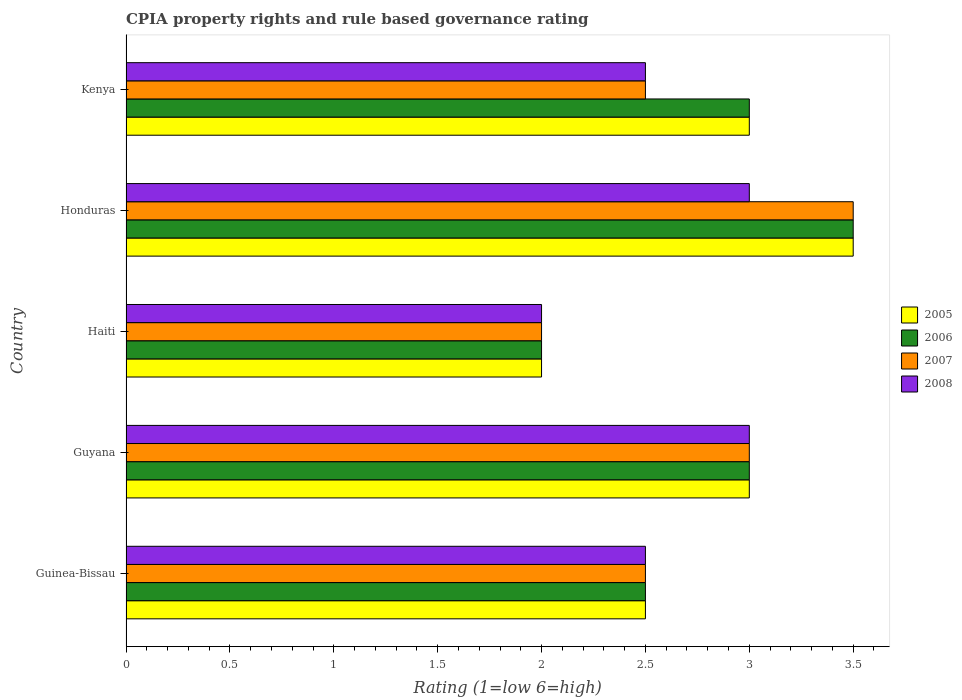Are the number of bars per tick equal to the number of legend labels?
Ensure brevity in your answer.  Yes. Are the number of bars on each tick of the Y-axis equal?
Offer a very short reply. Yes. How many bars are there on the 5th tick from the top?
Keep it short and to the point. 4. What is the label of the 2nd group of bars from the top?
Your response must be concise. Honduras. In how many cases, is the number of bars for a given country not equal to the number of legend labels?
Ensure brevity in your answer.  0. Across all countries, what is the minimum CPIA rating in 2007?
Your answer should be compact. 2. In which country was the CPIA rating in 2006 maximum?
Your response must be concise. Honduras. In which country was the CPIA rating in 2007 minimum?
Make the answer very short. Haiti. What is the total CPIA rating in 2007 in the graph?
Provide a succinct answer. 13.5. What is the difference between the CPIA rating in 2005 in Haiti and the CPIA rating in 2007 in Kenya?
Offer a very short reply. -0.5. In how many countries, is the CPIA rating in 2007 greater than 2.8 ?
Your answer should be very brief. 2. What is the ratio of the CPIA rating in 2006 in Guinea-Bissau to that in Honduras?
Offer a very short reply. 0.71. Is the difference between the CPIA rating in 2008 in Guyana and Kenya greater than the difference between the CPIA rating in 2005 in Guyana and Kenya?
Offer a terse response. Yes. What is the difference between the highest and the lowest CPIA rating in 2007?
Offer a terse response. 1.5. Is it the case that in every country, the sum of the CPIA rating in 2005 and CPIA rating in 2006 is greater than the sum of CPIA rating in 2007 and CPIA rating in 2008?
Offer a terse response. No. Is it the case that in every country, the sum of the CPIA rating in 2008 and CPIA rating in 2005 is greater than the CPIA rating in 2007?
Your answer should be very brief. Yes. How many bars are there?
Make the answer very short. 20. How many countries are there in the graph?
Offer a very short reply. 5. What is the difference between two consecutive major ticks on the X-axis?
Give a very brief answer. 0.5. Does the graph contain any zero values?
Make the answer very short. No. Does the graph contain grids?
Provide a short and direct response. No. Where does the legend appear in the graph?
Provide a succinct answer. Center right. How many legend labels are there?
Your answer should be very brief. 4. What is the title of the graph?
Provide a succinct answer. CPIA property rights and rule based governance rating. What is the label or title of the Y-axis?
Provide a short and direct response. Country. What is the Rating (1=low 6=high) in 2005 in Guinea-Bissau?
Make the answer very short. 2.5. What is the Rating (1=low 6=high) of 2005 in Guyana?
Your answer should be compact. 3. What is the Rating (1=low 6=high) of 2006 in Guyana?
Provide a succinct answer. 3. What is the Rating (1=low 6=high) in 2007 in Guyana?
Your answer should be very brief. 3. What is the Rating (1=low 6=high) of 2008 in Guyana?
Your response must be concise. 3. What is the Rating (1=low 6=high) in 2006 in Haiti?
Offer a terse response. 2. What is the Rating (1=low 6=high) in 2005 in Honduras?
Offer a terse response. 3.5. What is the Rating (1=low 6=high) of 2008 in Honduras?
Ensure brevity in your answer.  3. What is the Rating (1=low 6=high) of 2005 in Kenya?
Offer a terse response. 3. What is the Rating (1=low 6=high) in 2006 in Kenya?
Offer a very short reply. 3. Across all countries, what is the maximum Rating (1=low 6=high) in 2006?
Offer a terse response. 3.5. Across all countries, what is the maximum Rating (1=low 6=high) in 2007?
Provide a succinct answer. 3.5. Across all countries, what is the minimum Rating (1=low 6=high) in 2005?
Your response must be concise. 2. Across all countries, what is the minimum Rating (1=low 6=high) of 2008?
Offer a very short reply. 2. What is the total Rating (1=low 6=high) in 2007 in the graph?
Make the answer very short. 13.5. What is the total Rating (1=low 6=high) in 2008 in the graph?
Provide a succinct answer. 13. What is the difference between the Rating (1=low 6=high) of 2005 in Guinea-Bissau and that in Guyana?
Keep it short and to the point. -0.5. What is the difference between the Rating (1=low 6=high) of 2006 in Guinea-Bissau and that in Guyana?
Make the answer very short. -0.5. What is the difference between the Rating (1=low 6=high) in 2006 in Guinea-Bissau and that in Haiti?
Provide a short and direct response. 0.5. What is the difference between the Rating (1=low 6=high) in 2007 in Guinea-Bissau and that in Haiti?
Make the answer very short. 0.5. What is the difference between the Rating (1=low 6=high) of 2008 in Guinea-Bissau and that in Haiti?
Your response must be concise. 0.5. What is the difference between the Rating (1=low 6=high) in 2005 in Guinea-Bissau and that in Honduras?
Give a very brief answer. -1. What is the difference between the Rating (1=low 6=high) in 2006 in Guinea-Bissau and that in Honduras?
Provide a succinct answer. -1. What is the difference between the Rating (1=low 6=high) of 2007 in Guinea-Bissau and that in Honduras?
Provide a short and direct response. -1. What is the difference between the Rating (1=low 6=high) in 2008 in Guinea-Bissau and that in Kenya?
Provide a succinct answer. 0. What is the difference between the Rating (1=low 6=high) of 2005 in Guyana and that in Haiti?
Offer a very short reply. 1. What is the difference between the Rating (1=low 6=high) in 2006 in Guyana and that in Haiti?
Keep it short and to the point. 1. What is the difference between the Rating (1=low 6=high) of 2008 in Guyana and that in Haiti?
Make the answer very short. 1. What is the difference between the Rating (1=low 6=high) in 2005 in Guyana and that in Honduras?
Make the answer very short. -0.5. What is the difference between the Rating (1=low 6=high) of 2007 in Guyana and that in Honduras?
Ensure brevity in your answer.  -0.5. What is the difference between the Rating (1=low 6=high) in 2008 in Guyana and that in Honduras?
Offer a very short reply. 0. What is the difference between the Rating (1=low 6=high) of 2007 in Guyana and that in Kenya?
Your answer should be very brief. 0.5. What is the difference between the Rating (1=low 6=high) in 2006 in Haiti and that in Honduras?
Provide a short and direct response. -1.5. What is the difference between the Rating (1=low 6=high) in 2008 in Haiti and that in Kenya?
Your answer should be very brief. -0.5. What is the difference between the Rating (1=low 6=high) of 2005 in Honduras and that in Kenya?
Provide a short and direct response. 0.5. What is the difference between the Rating (1=low 6=high) of 2006 in Honduras and that in Kenya?
Provide a short and direct response. 0.5. What is the difference between the Rating (1=low 6=high) in 2007 in Honduras and that in Kenya?
Your answer should be compact. 1. What is the difference between the Rating (1=low 6=high) in 2005 in Guinea-Bissau and the Rating (1=low 6=high) in 2006 in Guyana?
Offer a terse response. -0.5. What is the difference between the Rating (1=low 6=high) of 2005 in Guinea-Bissau and the Rating (1=low 6=high) of 2007 in Guyana?
Your response must be concise. -0.5. What is the difference between the Rating (1=low 6=high) in 2005 in Guinea-Bissau and the Rating (1=low 6=high) in 2008 in Guyana?
Your response must be concise. -0.5. What is the difference between the Rating (1=low 6=high) in 2006 in Guinea-Bissau and the Rating (1=low 6=high) in 2007 in Guyana?
Keep it short and to the point. -0.5. What is the difference between the Rating (1=low 6=high) in 2006 in Guinea-Bissau and the Rating (1=low 6=high) in 2008 in Guyana?
Offer a terse response. -0.5. What is the difference between the Rating (1=low 6=high) in 2006 in Guinea-Bissau and the Rating (1=low 6=high) in 2007 in Haiti?
Provide a succinct answer. 0.5. What is the difference between the Rating (1=low 6=high) in 2006 in Guinea-Bissau and the Rating (1=low 6=high) in 2008 in Haiti?
Keep it short and to the point. 0.5. What is the difference between the Rating (1=low 6=high) in 2007 in Guinea-Bissau and the Rating (1=low 6=high) in 2008 in Haiti?
Offer a very short reply. 0.5. What is the difference between the Rating (1=low 6=high) in 2006 in Guinea-Bissau and the Rating (1=low 6=high) in 2008 in Honduras?
Keep it short and to the point. -0.5. What is the difference between the Rating (1=low 6=high) of 2005 in Guinea-Bissau and the Rating (1=low 6=high) of 2006 in Kenya?
Keep it short and to the point. -0.5. What is the difference between the Rating (1=low 6=high) in 2005 in Guinea-Bissau and the Rating (1=low 6=high) in 2007 in Kenya?
Give a very brief answer. 0. What is the difference between the Rating (1=low 6=high) in 2007 in Guinea-Bissau and the Rating (1=low 6=high) in 2008 in Kenya?
Your response must be concise. 0. What is the difference between the Rating (1=low 6=high) in 2005 in Guyana and the Rating (1=low 6=high) in 2007 in Haiti?
Your response must be concise. 1. What is the difference between the Rating (1=low 6=high) in 2005 in Guyana and the Rating (1=low 6=high) in 2008 in Haiti?
Make the answer very short. 1. What is the difference between the Rating (1=low 6=high) of 2006 in Guyana and the Rating (1=low 6=high) of 2007 in Haiti?
Make the answer very short. 1. What is the difference between the Rating (1=low 6=high) of 2005 in Guyana and the Rating (1=low 6=high) of 2007 in Honduras?
Offer a terse response. -0.5. What is the difference between the Rating (1=low 6=high) in 2005 in Guyana and the Rating (1=low 6=high) in 2007 in Kenya?
Your answer should be very brief. 0.5. What is the difference between the Rating (1=low 6=high) of 2006 in Guyana and the Rating (1=low 6=high) of 2007 in Kenya?
Your answer should be very brief. 0.5. What is the difference between the Rating (1=low 6=high) of 2007 in Guyana and the Rating (1=low 6=high) of 2008 in Kenya?
Make the answer very short. 0.5. What is the difference between the Rating (1=low 6=high) of 2005 in Haiti and the Rating (1=low 6=high) of 2006 in Honduras?
Provide a short and direct response. -1.5. What is the difference between the Rating (1=low 6=high) of 2006 in Haiti and the Rating (1=low 6=high) of 2007 in Honduras?
Your response must be concise. -1.5. What is the difference between the Rating (1=low 6=high) in 2007 in Haiti and the Rating (1=low 6=high) in 2008 in Honduras?
Your answer should be very brief. -1. What is the difference between the Rating (1=low 6=high) of 2005 in Haiti and the Rating (1=low 6=high) of 2006 in Kenya?
Make the answer very short. -1. What is the difference between the Rating (1=low 6=high) in 2005 in Haiti and the Rating (1=low 6=high) in 2007 in Kenya?
Offer a terse response. -0.5. What is the difference between the Rating (1=low 6=high) in 2005 in Haiti and the Rating (1=low 6=high) in 2008 in Kenya?
Give a very brief answer. -0.5. What is the difference between the Rating (1=low 6=high) of 2005 in Honduras and the Rating (1=low 6=high) of 2007 in Kenya?
Make the answer very short. 1. What is the average Rating (1=low 6=high) of 2005 per country?
Ensure brevity in your answer.  2.8. What is the average Rating (1=low 6=high) of 2006 per country?
Your answer should be very brief. 2.8. What is the average Rating (1=low 6=high) of 2007 per country?
Give a very brief answer. 2.7. What is the average Rating (1=low 6=high) in 2008 per country?
Offer a terse response. 2.6. What is the difference between the Rating (1=low 6=high) in 2005 and Rating (1=low 6=high) in 2007 in Guinea-Bissau?
Offer a very short reply. 0. What is the difference between the Rating (1=low 6=high) in 2006 and Rating (1=low 6=high) in 2007 in Guinea-Bissau?
Provide a short and direct response. 0. What is the difference between the Rating (1=low 6=high) of 2006 and Rating (1=low 6=high) of 2008 in Guinea-Bissau?
Your response must be concise. 0. What is the difference between the Rating (1=low 6=high) of 2006 and Rating (1=low 6=high) of 2008 in Guyana?
Provide a succinct answer. 0. What is the difference between the Rating (1=low 6=high) in 2005 and Rating (1=low 6=high) in 2007 in Haiti?
Your response must be concise. 0. What is the difference between the Rating (1=low 6=high) in 2006 and Rating (1=low 6=high) in 2008 in Haiti?
Your answer should be very brief. 0. What is the difference between the Rating (1=low 6=high) of 2007 and Rating (1=low 6=high) of 2008 in Haiti?
Provide a short and direct response. 0. What is the difference between the Rating (1=low 6=high) in 2005 and Rating (1=low 6=high) in 2007 in Honduras?
Offer a very short reply. 0. What is the difference between the Rating (1=low 6=high) in 2006 and Rating (1=low 6=high) in 2007 in Honduras?
Give a very brief answer. 0. What is the difference between the Rating (1=low 6=high) of 2007 and Rating (1=low 6=high) of 2008 in Honduras?
Offer a very short reply. 0.5. What is the difference between the Rating (1=low 6=high) of 2005 and Rating (1=low 6=high) of 2007 in Kenya?
Your answer should be very brief. 0.5. What is the difference between the Rating (1=low 6=high) of 2006 and Rating (1=low 6=high) of 2007 in Kenya?
Make the answer very short. 0.5. What is the difference between the Rating (1=low 6=high) of 2006 and Rating (1=low 6=high) of 2008 in Kenya?
Ensure brevity in your answer.  0.5. What is the ratio of the Rating (1=low 6=high) of 2008 in Guinea-Bissau to that in Guyana?
Offer a terse response. 0.83. What is the ratio of the Rating (1=low 6=high) in 2005 in Guinea-Bissau to that in Haiti?
Make the answer very short. 1.25. What is the ratio of the Rating (1=low 6=high) in 2008 in Guinea-Bissau to that in Haiti?
Your answer should be very brief. 1.25. What is the ratio of the Rating (1=low 6=high) in 2005 in Guinea-Bissau to that in Honduras?
Your answer should be compact. 0.71. What is the ratio of the Rating (1=low 6=high) in 2006 in Guinea-Bissau to that in Honduras?
Keep it short and to the point. 0.71. What is the ratio of the Rating (1=low 6=high) of 2008 in Guinea-Bissau to that in Honduras?
Keep it short and to the point. 0.83. What is the ratio of the Rating (1=low 6=high) of 2007 in Guinea-Bissau to that in Kenya?
Offer a terse response. 1. What is the ratio of the Rating (1=low 6=high) of 2005 in Guyana to that in Haiti?
Offer a terse response. 1.5. What is the ratio of the Rating (1=low 6=high) in 2006 in Guyana to that in Haiti?
Provide a short and direct response. 1.5. What is the ratio of the Rating (1=low 6=high) of 2007 in Guyana to that in Haiti?
Provide a succinct answer. 1.5. What is the ratio of the Rating (1=low 6=high) in 2005 in Guyana to that in Honduras?
Provide a succinct answer. 0.86. What is the ratio of the Rating (1=low 6=high) in 2006 in Guyana to that in Honduras?
Offer a very short reply. 0.86. What is the ratio of the Rating (1=low 6=high) in 2007 in Guyana to that in Honduras?
Keep it short and to the point. 0.86. What is the ratio of the Rating (1=low 6=high) in 2008 in Guyana to that in Honduras?
Your answer should be compact. 1. What is the ratio of the Rating (1=low 6=high) of 2005 in Guyana to that in Kenya?
Offer a very short reply. 1. What is the ratio of the Rating (1=low 6=high) in 2008 in Guyana to that in Kenya?
Provide a succinct answer. 1.2. What is the ratio of the Rating (1=low 6=high) of 2005 in Haiti to that in Honduras?
Ensure brevity in your answer.  0.57. What is the ratio of the Rating (1=low 6=high) in 2006 in Haiti to that in Honduras?
Offer a very short reply. 0.57. What is the ratio of the Rating (1=low 6=high) in 2006 in Haiti to that in Kenya?
Ensure brevity in your answer.  0.67. What is the ratio of the Rating (1=low 6=high) in 2007 in Haiti to that in Kenya?
Your answer should be compact. 0.8. What is the ratio of the Rating (1=low 6=high) in 2006 in Honduras to that in Kenya?
Make the answer very short. 1.17. What is the ratio of the Rating (1=low 6=high) of 2007 in Honduras to that in Kenya?
Your answer should be very brief. 1.4. What is the ratio of the Rating (1=low 6=high) in 2008 in Honduras to that in Kenya?
Give a very brief answer. 1.2. What is the difference between the highest and the second highest Rating (1=low 6=high) of 2006?
Your answer should be very brief. 0.5. What is the difference between the highest and the second highest Rating (1=low 6=high) of 2008?
Keep it short and to the point. 0. What is the difference between the highest and the lowest Rating (1=low 6=high) in 2005?
Your response must be concise. 1.5. What is the difference between the highest and the lowest Rating (1=low 6=high) of 2006?
Provide a succinct answer. 1.5. What is the difference between the highest and the lowest Rating (1=low 6=high) of 2008?
Your answer should be very brief. 1. 